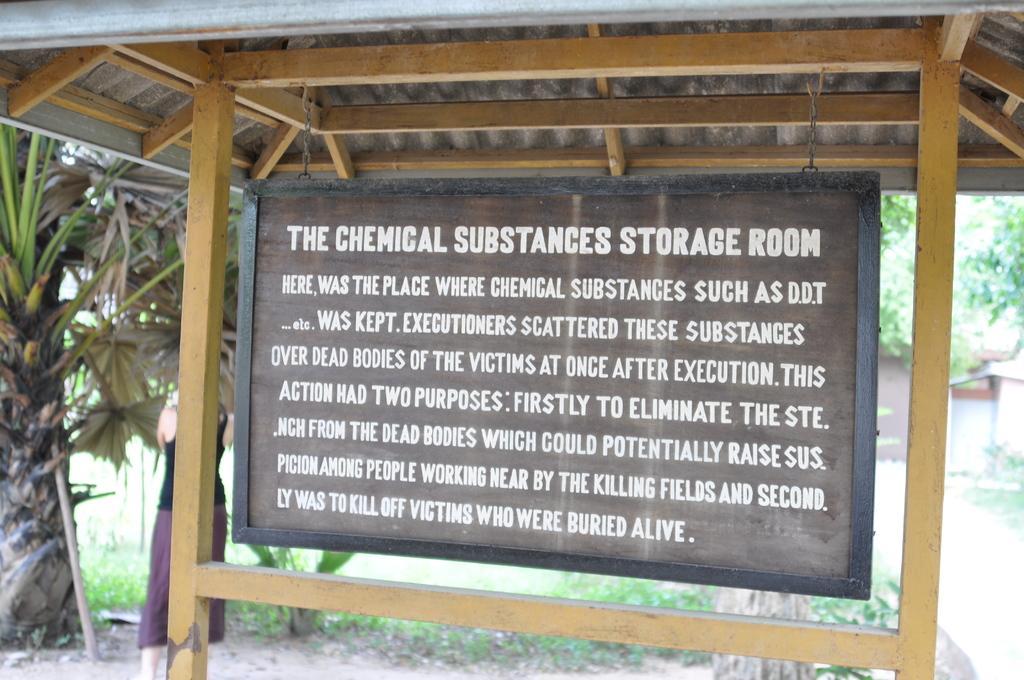Could you give a brief overview of what you see in this image? In the middle of the image we can see a board and we can find some text, beside the board we can see a person, in the background we can find few trees. 